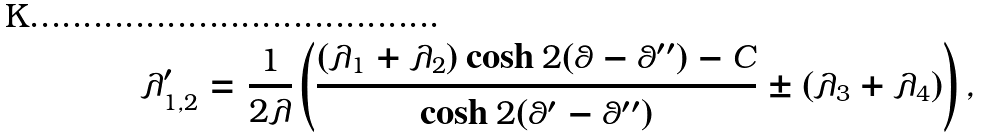<formula> <loc_0><loc_0><loc_500><loc_500>\lambda _ { 1 , 2 } ^ { \prime } = \frac { 1 } { 2 \lambda } \left ( \frac { ( \lambda _ { 1 } + \lambda _ { 2 } ) \cosh { 2 ( \theta - \theta ^ { \prime \prime } ) } - C } { \cosh { 2 ( \theta ^ { \prime } - \theta ^ { \prime \prime } ) } } \pm ( \lambda _ { 3 } + \lambda _ { 4 } ) \right ) ,</formula> 